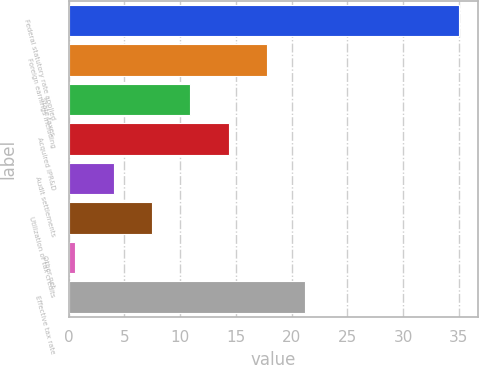<chart> <loc_0><loc_0><loc_500><loc_500><bar_chart><fcel>Federal statutory rate applied<fcel>Foreign earnings including<fcel>State taxes<fcel>Acquired IPR&D<fcel>Audit settlements<fcel>Utilization of tax credits<fcel>Other net<fcel>Effective tax rate<nl><fcel>35<fcel>17.8<fcel>10.92<fcel>14.36<fcel>4.04<fcel>7.48<fcel>0.6<fcel>21.24<nl></chart> 